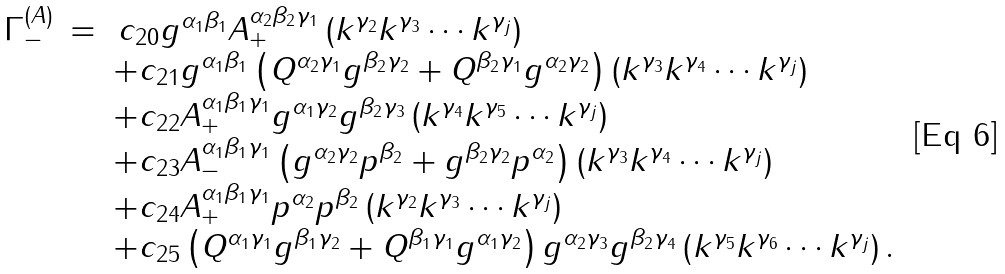<formula> <loc_0><loc_0><loc_500><loc_500>\begin{array} { r c l } \Gamma _ { - } ^ { ( A ) } & = & \, c _ { 2 0 } g ^ { \alpha _ { 1 } \beta _ { 1 } } A _ { + } ^ { \alpha _ { 2 } \beta _ { 2 } \gamma _ { 1 } } \left ( k ^ { \gamma _ { 2 } } k ^ { \gamma _ { 3 } } \cdots k ^ { \gamma _ { j } } \right ) \\ & & + c _ { 2 1 } g ^ { \alpha _ { 1 } \beta _ { 1 } } \left ( Q ^ { \alpha _ { 2 } \gamma _ { 1 } } g ^ { \beta _ { 2 } \gamma _ { 2 } } + Q ^ { \beta _ { 2 } \gamma _ { 1 } } g ^ { \alpha _ { 2 } \gamma _ { 2 } } \right ) \left ( k ^ { \gamma _ { 3 } } k ^ { \gamma _ { 4 } } \cdots k ^ { \gamma _ { j } } \right ) \\ & & + c _ { 2 2 } A _ { + } ^ { \alpha _ { 1 } \beta _ { 1 } \gamma _ { 1 } } g ^ { \alpha _ { 1 } \gamma _ { 2 } } g ^ { \beta _ { 2 } \gamma _ { 3 } } \left ( k ^ { \gamma _ { 4 } } k ^ { \gamma _ { 5 } } \cdots k ^ { \gamma _ { j } } \right ) \\ & & + c _ { 2 3 } A _ { - } ^ { \alpha _ { 1 } \beta _ { 1 } \gamma _ { 1 } } \left ( g ^ { \alpha _ { 2 } \gamma _ { 2 } } p ^ { \beta _ { 2 } } + g ^ { \beta _ { 2 } \gamma _ { 2 } } p ^ { \alpha _ { 2 } } \right ) \left ( k ^ { \gamma _ { 3 } } k ^ { \gamma _ { 4 } } \cdots k ^ { \gamma _ { j } } \right ) \\ & & + c _ { 2 4 } A _ { + } ^ { \alpha _ { 1 } \beta _ { 1 } \gamma _ { 1 } } p ^ { \alpha _ { 2 } } p ^ { \beta _ { 2 } } \left ( k ^ { \gamma _ { 2 } } k ^ { \gamma _ { 3 } } \cdots k ^ { \gamma _ { j } } \right ) \\ & & + c _ { 2 5 } \left ( Q ^ { \alpha _ { 1 } \gamma _ { 1 } } g ^ { \beta _ { 1 } \gamma _ { 2 } } + Q ^ { \beta _ { 1 } \gamma _ { 1 } } g ^ { \alpha _ { 1 } \gamma _ { 2 } } \right ) g ^ { \alpha _ { 2 } \gamma _ { 3 } } g ^ { \beta _ { 2 } \gamma _ { 4 } } \left ( k ^ { \gamma _ { 5 } } k ^ { \gamma _ { 6 } } \cdots k ^ { \gamma _ { j } } \right ) . \end{array}</formula> 